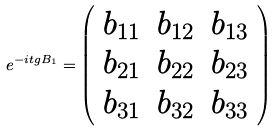<formula> <loc_0><loc_0><loc_500><loc_500>e ^ { - i t g B _ { 1 } } = \left ( \begin{array} { c c c } b _ { 1 1 } & b _ { 1 2 } & b _ { 1 3 } \\ b _ { 2 1 } & b _ { 2 2 } & b _ { 2 3 } \\ b _ { 3 1 } & b _ { 3 2 } & b _ { 3 3 } \end{array} \right )</formula> 